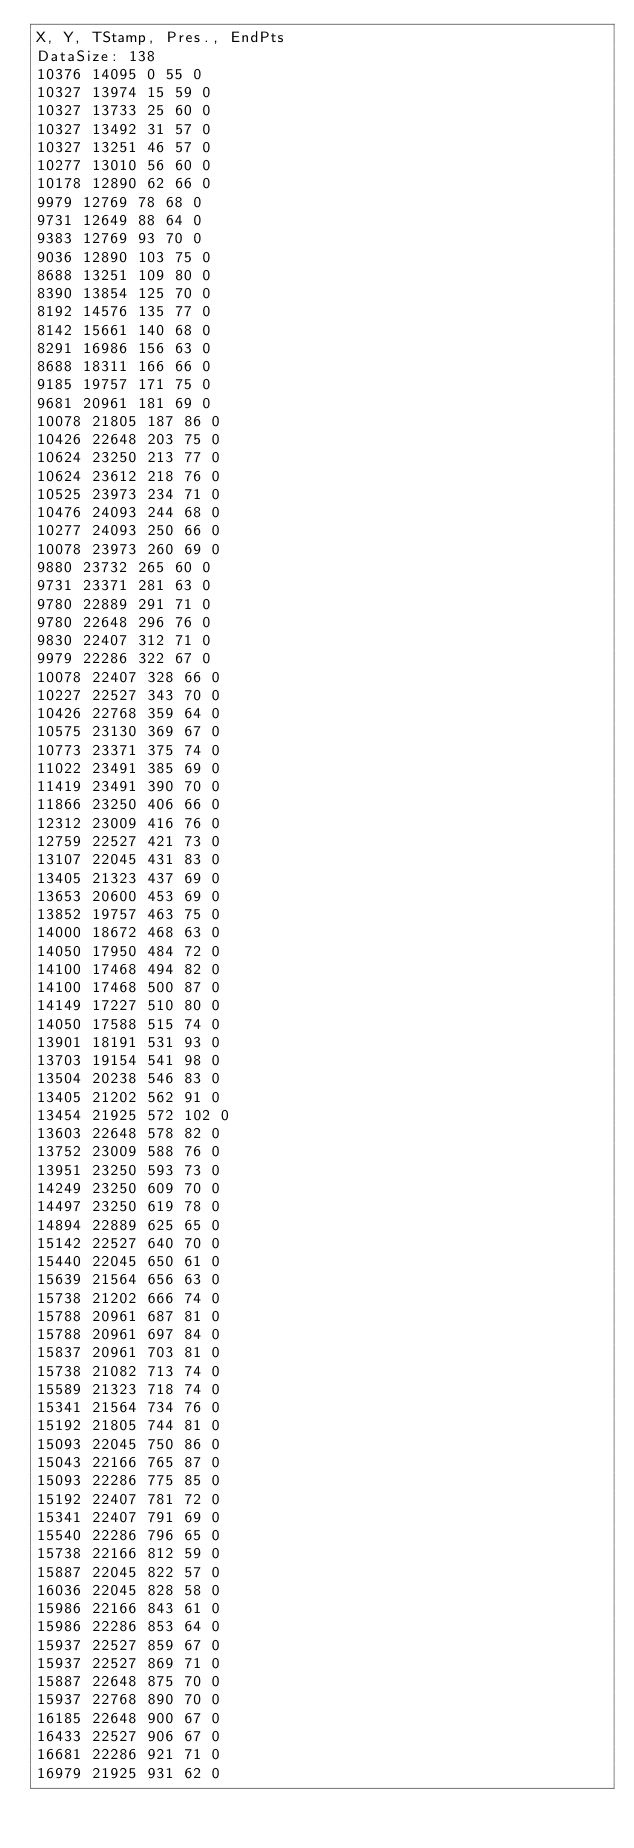Convert code to text. <code><loc_0><loc_0><loc_500><loc_500><_SML_>X, Y, TStamp, Pres., EndPts
DataSize: 138
10376 14095 0 55 0
10327 13974 15 59 0
10327 13733 25 60 0
10327 13492 31 57 0
10327 13251 46 57 0
10277 13010 56 60 0
10178 12890 62 66 0
9979 12769 78 68 0
9731 12649 88 64 0
9383 12769 93 70 0
9036 12890 103 75 0
8688 13251 109 80 0
8390 13854 125 70 0
8192 14576 135 77 0
8142 15661 140 68 0
8291 16986 156 63 0
8688 18311 166 66 0
9185 19757 171 75 0
9681 20961 181 69 0
10078 21805 187 86 0
10426 22648 203 75 0
10624 23250 213 77 0
10624 23612 218 76 0
10525 23973 234 71 0
10476 24093 244 68 0
10277 24093 250 66 0
10078 23973 260 69 0
9880 23732 265 60 0
9731 23371 281 63 0
9780 22889 291 71 0
9780 22648 296 76 0
9830 22407 312 71 0
9979 22286 322 67 0
10078 22407 328 66 0
10227 22527 343 70 0
10426 22768 359 64 0
10575 23130 369 67 0
10773 23371 375 74 0
11022 23491 385 69 0
11419 23491 390 70 0
11866 23250 406 66 0
12312 23009 416 76 0
12759 22527 421 73 0
13107 22045 431 83 0
13405 21323 437 69 0
13653 20600 453 69 0
13852 19757 463 75 0
14000 18672 468 63 0
14050 17950 484 72 0
14100 17468 494 82 0
14100 17468 500 87 0
14149 17227 510 80 0
14050 17588 515 74 0
13901 18191 531 93 0
13703 19154 541 98 0
13504 20238 546 83 0
13405 21202 562 91 0
13454 21925 572 102 0
13603 22648 578 82 0
13752 23009 588 76 0
13951 23250 593 73 0
14249 23250 609 70 0
14497 23250 619 78 0
14894 22889 625 65 0
15142 22527 640 70 0
15440 22045 650 61 0
15639 21564 656 63 0
15738 21202 666 74 0
15788 20961 687 81 0
15788 20961 697 84 0
15837 20961 703 81 0
15738 21082 713 74 0
15589 21323 718 74 0
15341 21564 734 76 0
15192 21805 744 81 0
15093 22045 750 86 0
15043 22166 765 87 0
15093 22286 775 85 0
15192 22407 781 72 0
15341 22407 791 69 0
15540 22286 796 65 0
15738 22166 812 59 0
15887 22045 822 57 0
16036 22045 828 58 0
15986 22166 843 61 0
15986 22286 853 64 0
15937 22527 859 67 0
15937 22527 869 71 0
15887 22648 875 70 0
15937 22768 890 70 0
16185 22648 900 67 0
16433 22527 906 67 0
16681 22286 921 71 0
16979 21925 931 62 0</code> 